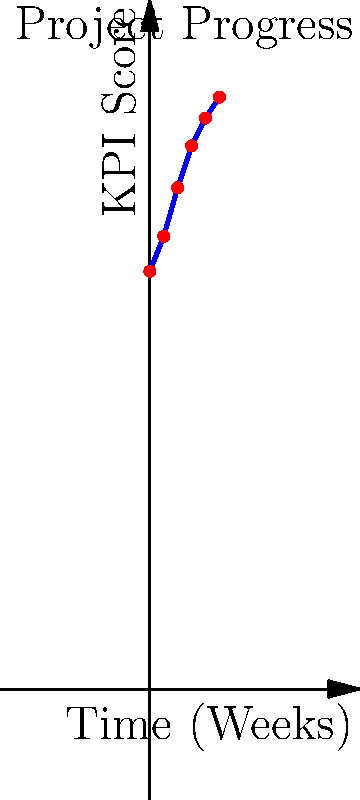As a senior manager, you're reviewing the project progress chart provided by your team lead. The graph shows the KPI score over time for a project. What is the approximate rate of increase in KPI score per week based on the data shown? To calculate the rate of increase in KPI score per week:

1. Identify the starting and ending points:
   Start: Week 0, KPI score 60
   End: Week 10, KPI score 85

2. Calculate the total change in KPI score:
   $\Delta KPI = 85 - 60 = 25$

3. Calculate the total time period:
   $\Delta Time = 10 - 0 = 10$ weeks

4. Use the formula for rate of change:
   $Rate = \frac{\Delta KPI}{\Delta Time} = \frac{25}{10} = 2.5$

Therefore, the approximate rate of increase in KPI score is 2.5 points per week.
Answer: 2.5 points per week 